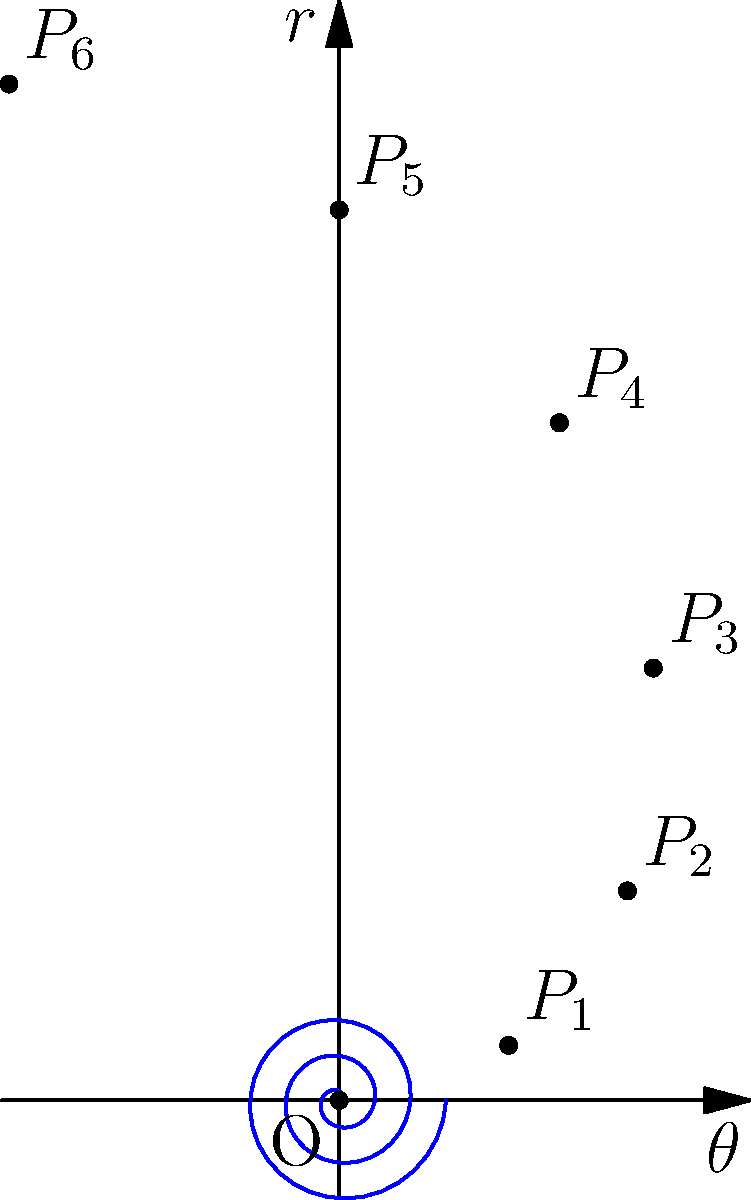In the context of disease outbreak analysis, the spiral graph above represents the spread of an infectious disease over time. If each complete revolution (2π) represents one week, and the radial distance from the origin indicates the number of new cases, what does point P₆ signify in terms of time elapsed and cumulative new cases since the outbreak began? To analyze this graph and answer the question, let's follow these steps:

1) First, we need to understand what the spiral represents:
   - Each complete revolution (2π) represents one week
   - The radial distance (r) from the origin indicates the number of new cases

2) Now, let's look at point P₆:
   - It's located at the end of the third complete revolution
   - This means it represents the end of the 3rd week

3) To calculate the time elapsed:
   - 3 weeks = 3 * 7 = 21 days

4) To calculate the cumulative new cases, we need to find the radial distance of P₆:
   - The equation of the spiral is $r = 0.1\theta$
   - At P₆, $\theta = 6\pi$
   - Therefore, $r = 0.1 * 6\pi = 0.6\pi \approx 1.88$

5) However, this 1.88 represents the new cases at the exact end of the 3rd week. To get the cumulative cases, we need to calculate the area under the spiral from 0 to 6π.

6) The formula for the area under a polar curve is:
   $A = \frac{1}{2}\int_{0}^{6\pi} r^2 d\theta$

7) Substituting our equation:
   $A = \frac{1}{2}\int_{0}^{6\pi} (0.1\theta)^2 d\theta$
   $= 0.005\int_{0}^{6\pi} \theta^2 d\theta$
   $= 0.005 [\frac{1}{3}\theta^3]_{0}^{6\pi}$
   $= 0.005 * \frac{1}{3} * (6\pi)^3$
   $\approx 7.12$

Therefore, P₆ signifies 21 days since the outbreak began, with approximately 7 cumulative new cases.
Answer: 21 days, 7 cases 